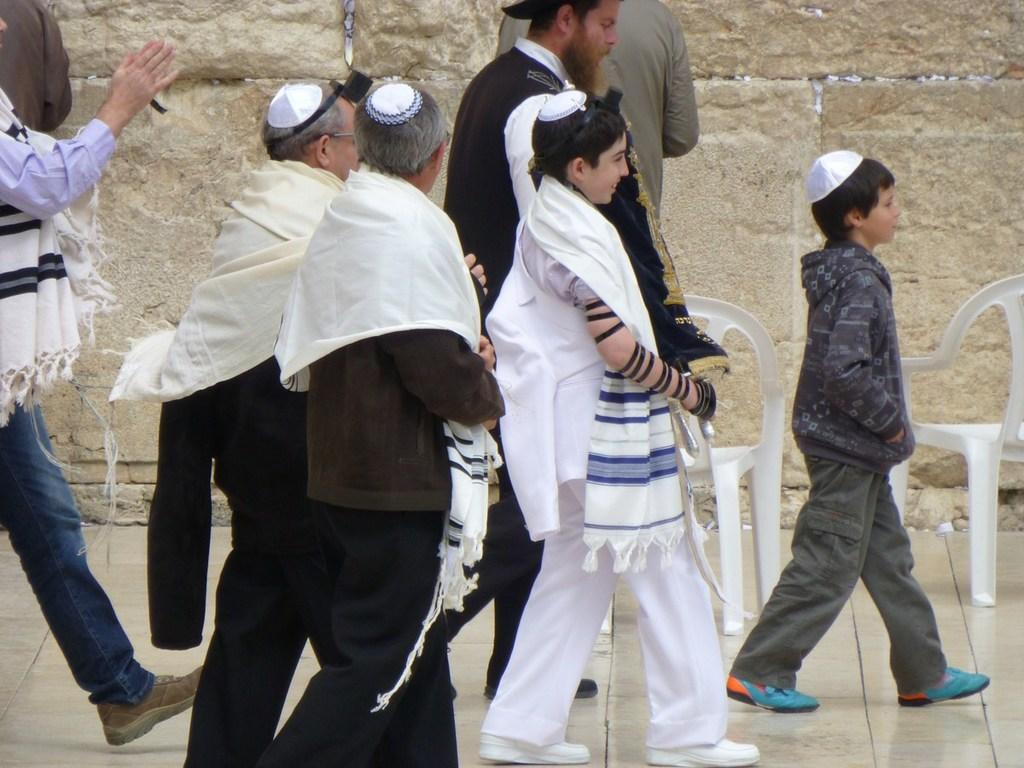What is at the bottom of the image? There is a floor at the bottom of the image. What can be seen in the foreground of the image? There are people and chairs in the foreground of the image. What is visible in the background of the image? There is a wall in the background of the image. How many sheep are present in the image? There are no sheep present in the image. What position are the people in the image sitting in? The provided facts do not mention the position of the people in the image, so we cannot determine their position from the information given. 